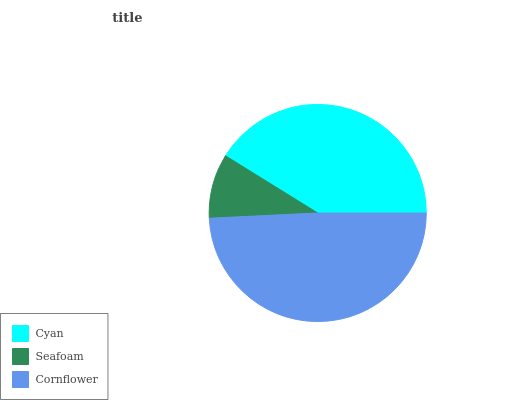Is Seafoam the minimum?
Answer yes or no. Yes. Is Cornflower the maximum?
Answer yes or no. Yes. Is Cornflower the minimum?
Answer yes or no. No. Is Seafoam the maximum?
Answer yes or no. No. Is Cornflower greater than Seafoam?
Answer yes or no. Yes. Is Seafoam less than Cornflower?
Answer yes or no. Yes. Is Seafoam greater than Cornflower?
Answer yes or no. No. Is Cornflower less than Seafoam?
Answer yes or no. No. Is Cyan the high median?
Answer yes or no. Yes. Is Cyan the low median?
Answer yes or no. Yes. Is Cornflower the high median?
Answer yes or no. No. Is Cornflower the low median?
Answer yes or no. No. 